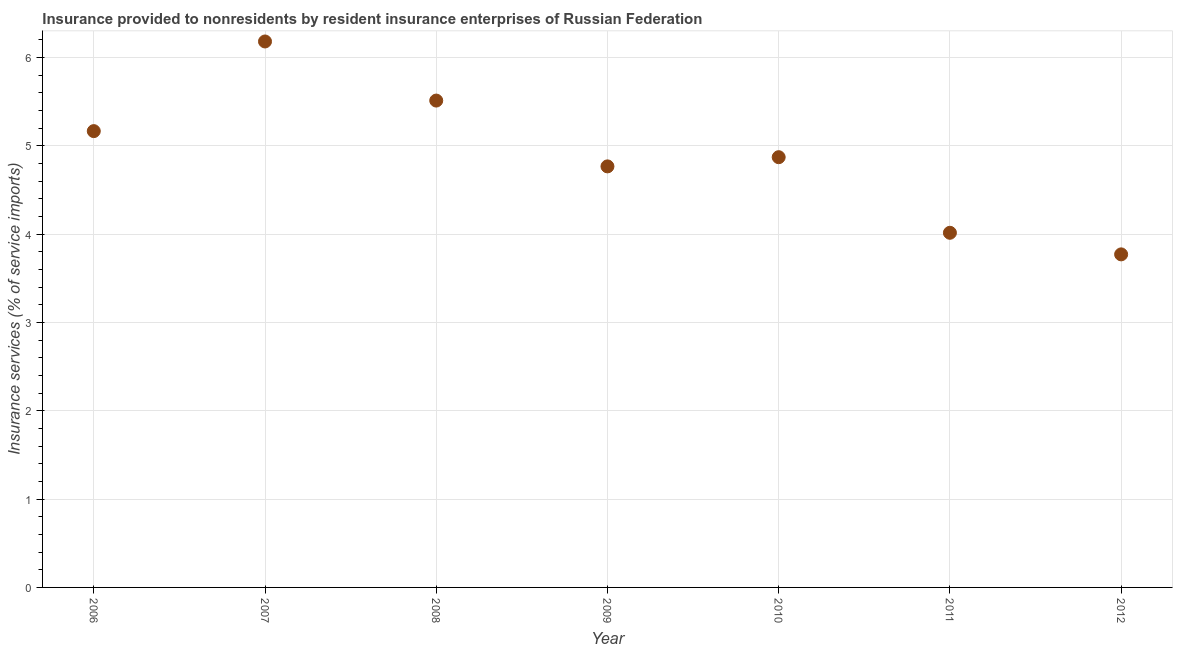What is the insurance and financial services in 2009?
Your answer should be compact. 4.77. Across all years, what is the maximum insurance and financial services?
Your answer should be very brief. 6.18. Across all years, what is the minimum insurance and financial services?
Provide a succinct answer. 3.77. In which year was the insurance and financial services maximum?
Your response must be concise. 2007. What is the sum of the insurance and financial services?
Your response must be concise. 34.29. What is the difference between the insurance and financial services in 2010 and 2012?
Ensure brevity in your answer.  1.1. What is the average insurance and financial services per year?
Your response must be concise. 4.9. What is the median insurance and financial services?
Provide a succinct answer. 4.87. What is the ratio of the insurance and financial services in 2006 to that in 2010?
Ensure brevity in your answer.  1.06. Is the insurance and financial services in 2009 less than that in 2012?
Offer a very short reply. No. What is the difference between the highest and the second highest insurance and financial services?
Provide a succinct answer. 0.67. Is the sum of the insurance and financial services in 2006 and 2010 greater than the maximum insurance and financial services across all years?
Your answer should be compact. Yes. What is the difference between the highest and the lowest insurance and financial services?
Provide a short and direct response. 2.41. Does the insurance and financial services monotonically increase over the years?
Offer a terse response. No. Are the values on the major ticks of Y-axis written in scientific E-notation?
Offer a very short reply. No. Does the graph contain grids?
Ensure brevity in your answer.  Yes. What is the title of the graph?
Keep it short and to the point. Insurance provided to nonresidents by resident insurance enterprises of Russian Federation. What is the label or title of the X-axis?
Provide a succinct answer. Year. What is the label or title of the Y-axis?
Keep it short and to the point. Insurance services (% of service imports). What is the Insurance services (% of service imports) in 2006?
Your response must be concise. 5.17. What is the Insurance services (% of service imports) in 2007?
Ensure brevity in your answer.  6.18. What is the Insurance services (% of service imports) in 2008?
Ensure brevity in your answer.  5.51. What is the Insurance services (% of service imports) in 2009?
Offer a terse response. 4.77. What is the Insurance services (% of service imports) in 2010?
Ensure brevity in your answer.  4.87. What is the Insurance services (% of service imports) in 2011?
Your response must be concise. 4.02. What is the Insurance services (% of service imports) in 2012?
Your answer should be very brief. 3.77. What is the difference between the Insurance services (% of service imports) in 2006 and 2007?
Give a very brief answer. -1.02. What is the difference between the Insurance services (% of service imports) in 2006 and 2008?
Keep it short and to the point. -0.35. What is the difference between the Insurance services (% of service imports) in 2006 and 2009?
Keep it short and to the point. 0.4. What is the difference between the Insurance services (% of service imports) in 2006 and 2010?
Give a very brief answer. 0.3. What is the difference between the Insurance services (% of service imports) in 2006 and 2011?
Your answer should be very brief. 1.15. What is the difference between the Insurance services (% of service imports) in 2006 and 2012?
Make the answer very short. 1.4. What is the difference between the Insurance services (% of service imports) in 2007 and 2008?
Offer a very short reply. 0.67. What is the difference between the Insurance services (% of service imports) in 2007 and 2009?
Offer a very short reply. 1.41. What is the difference between the Insurance services (% of service imports) in 2007 and 2010?
Your answer should be compact. 1.31. What is the difference between the Insurance services (% of service imports) in 2007 and 2011?
Provide a short and direct response. 2.17. What is the difference between the Insurance services (% of service imports) in 2007 and 2012?
Your response must be concise. 2.41. What is the difference between the Insurance services (% of service imports) in 2008 and 2009?
Offer a very short reply. 0.75. What is the difference between the Insurance services (% of service imports) in 2008 and 2010?
Provide a short and direct response. 0.64. What is the difference between the Insurance services (% of service imports) in 2008 and 2011?
Make the answer very short. 1.5. What is the difference between the Insurance services (% of service imports) in 2008 and 2012?
Ensure brevity in your answer.  1.74. What is the difference between the Insurance services (% of service imports) in 2009 and 2010?
Ensure brevity in your answer.  -0.1. What is the difference between the Insurance services (% of service imports) in 2009 and 2011?
Your answer should be very brief. 0.75. What is the difference between the Insurance services (% of service imports) in 2009 and 2012?
Make the answer very short. 1. What is the difference between the Insurance services (% of service imports) in 2010 and 2011?
Offer a very short reply. 0.86. What is the difference between the Insurance services (% of service imports) in 2010 and 2012?
Provide a succinct answer. 1.1. What is the difference between the Insurance services (% of service imports) in 2011 and 2012?
Make the answer very short. 0.24. What is the ratio of the Insurance services (% of service imports) in 2006 to that in 2007?
Offer a terse response. 0.84. What is the ratio of the Insurance services (% of service imports) in 2006 to that in 2008?
Your response must be concise. 0.94. What is the ratio of the Insurance services (% of service imports) in 2006 to that in 2009?
Offer a terse response. 1.08. What is the ratio of the Insurance services (% of service imports) in 2006 to that in 2010?
Provide a succinct answer. 1.06. What is the ratio of the Insurance services (% of service imports) in 2006 to that in 2011?
Offer a terse response. 1.29. What is the ratio of the Insurance services (% of service imports) in 2006 to that in 2012?
Keep it short and to the point. 1.37. What is the ratio of the Insurance services (% of service imports) in 2007 to that in 2008?
Make the answer very short. 1.12. What is the ratio of the Insurance services (% of service imports) in 2007 to that in 2009?
Offer a terse response. 1.3. What is the ratio of the Insurance services (% of service imports) in 2007 to that in 2010?
Make the answer very short. 1.27. What is the ratio of the Insurance services (% of service imports) in 2007 to that in 2011?
Offer a terse response. 1.54. What is the ratio of the Insurance services (% of service imports) in 2007 to that in 2012?
Give a very brief answer. 1.64. What is the ratio of the Insurance services (% of service imports) in 2008 to that in 2009?
Give a very brief answer. 1.16. What is the ratio of the Insurance services (% of service imports) in 2008 to that in 2010?
Give a very brief answer. 1.13. What is the ratio of the Insurance services (% of service imports) in 2008 to that in 2011?
Provide a short and direct response. 1.37. What is the ratio of the Insurance services (% of service imports) in 2008 to that in 2012?
Give a very brief answer. 1.46. What is the ratio of the Insurance services (% of service imports) in 2009 to that in 2010?
Provide a short and direct response. 0.98. What is the ratio of the Insurance services (% of service imports) in 2009 to that in 2011?
Offer a very short reply. 1.19. What is the ratio of the Insurance services (% of service imports) in 2009 to that in 2012?
Your answer should be very brief. 1.26. What is the ratio of the Insurance services (% of service imports) in 2010 to that in 2011?
Offer a terse response. 1.21. What is the ratio of the Insurance services (% of service imports) in 2010 to that in 2012?
Keep it short and to the point. 1.29. What is the ratio of the Insurance services (% of service imports) in 2011 to that in 2012?
Your answer should be very brief. 1.06. 